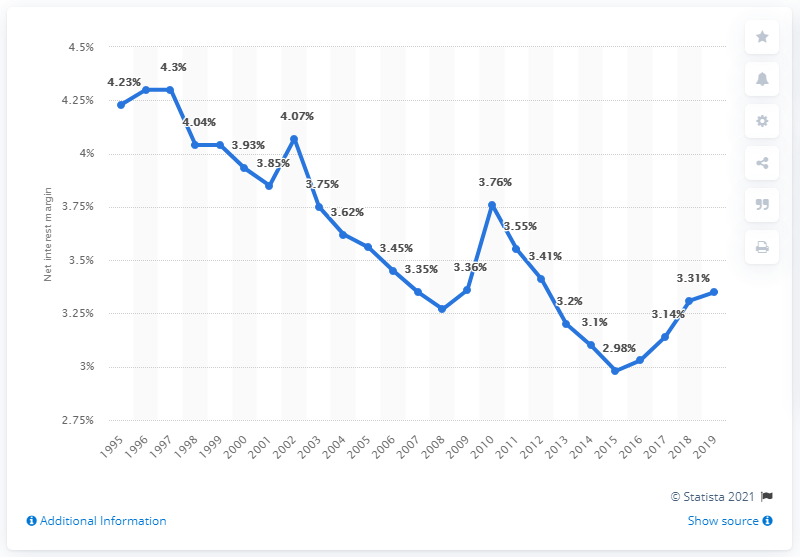Specify some key components in this picture. The net interest margin is a measure of the difference between the interest income generated by banks and other financial institutions and the amount of interest paid out to their lenders. This ratio provides insight into the profitability of these institutions and their ability to generate a return on their assets. The average net interest margin of U.S. banks in 2019 was 3.35. 